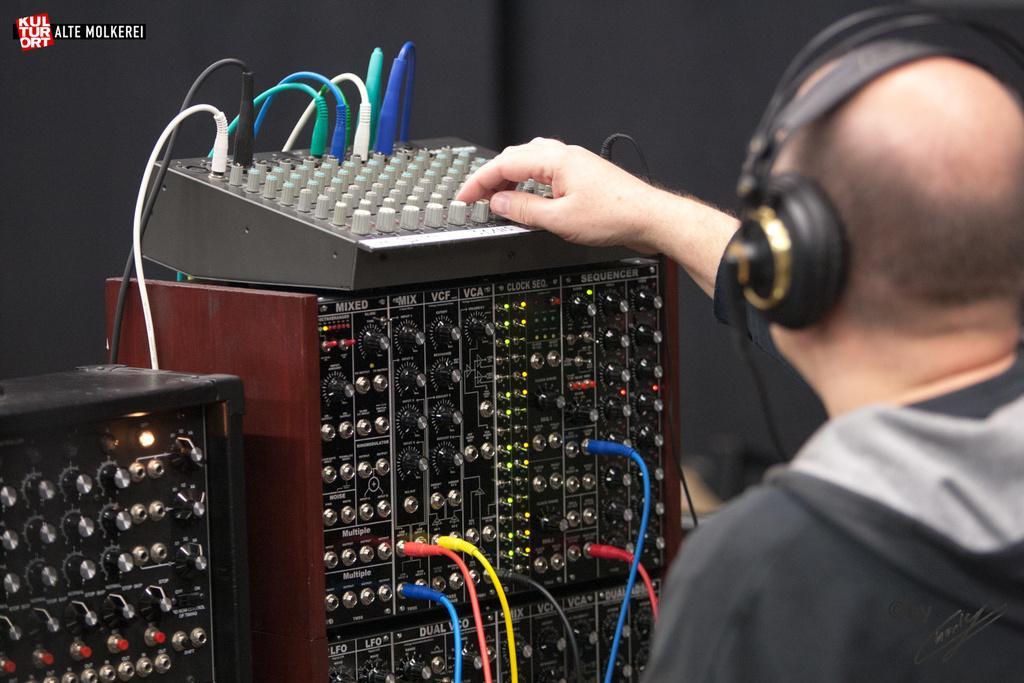Can you describe this image briefly? In this picture I can see there is a man standing on the right side and he is wearing a head set. There are some equipment in front of him and they are connected with cables and in the backdrop there is a black color wall. 